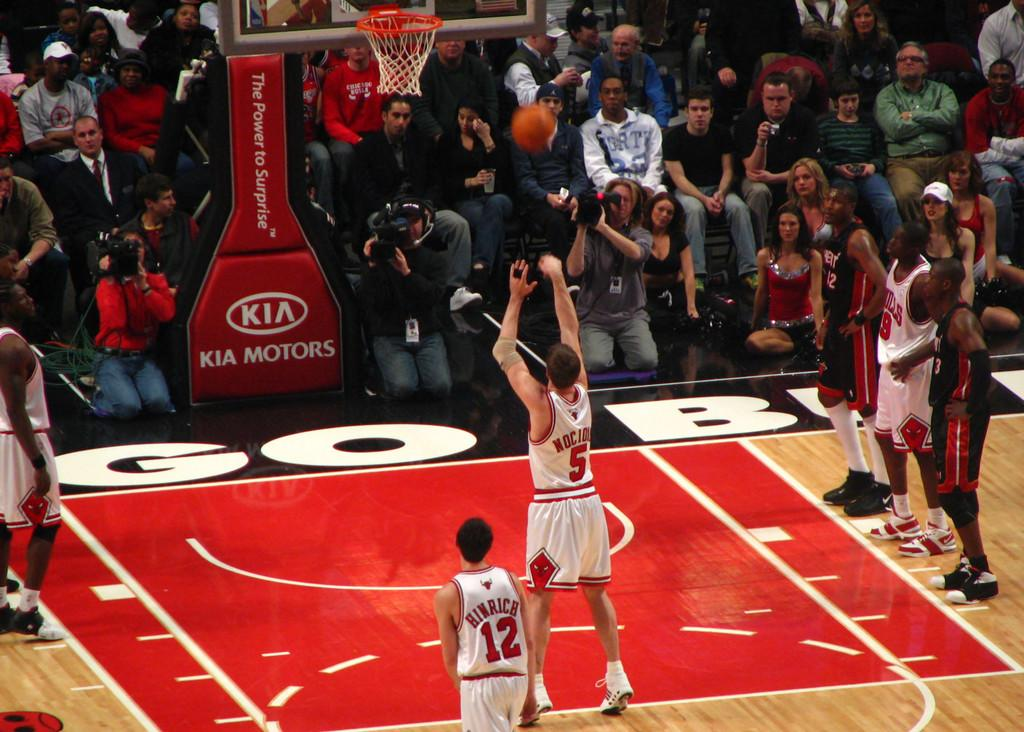<image>
Give a short and clear explanation of the subsequent image. some Bulls players with one player named Hinrich 